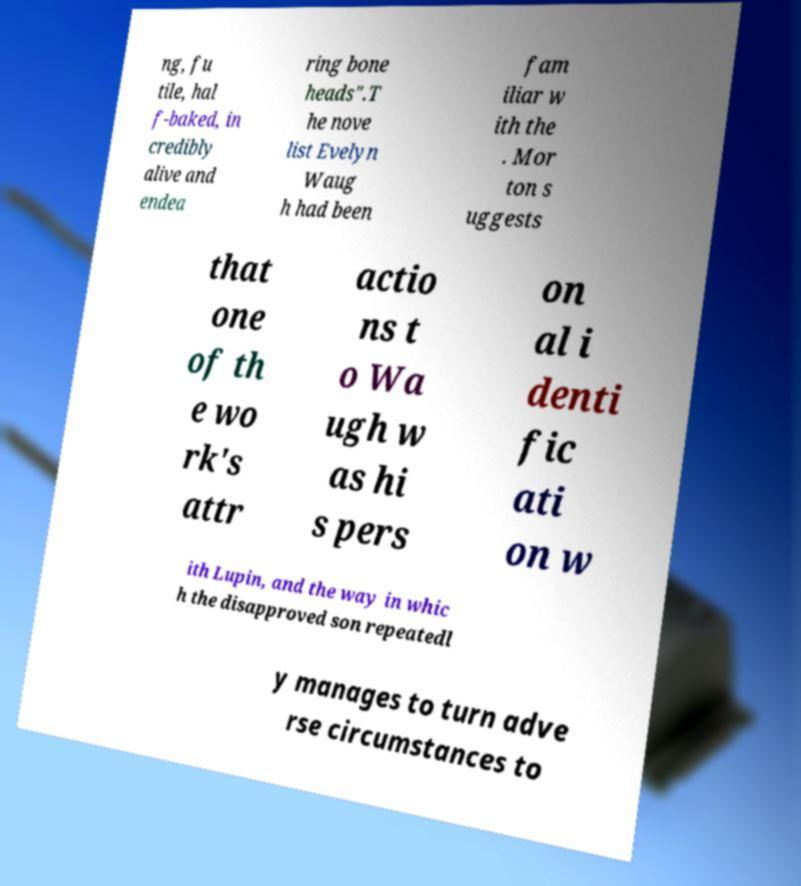For documentation purposes, I need the text within this image transcribed. Could you provide that? ng, fu tile, hal f-baked, in credibly alive and endea ring bone heads".T he nove list Evelyn Waug h had been fam iliar w ith the . Mor ton s uggests that one of th e wo rk's attr actio ns t o Wa ugh w as hi s pers on al i denti fic ati on w ith Lupin, and the way in whic h the disapproved son repeatedl y manages to turn adve rse circumstances to 